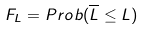Convert formula to latex. <formula><loc_0><loc_0><loc_500><loc_500>F _ { L } = P r o b ( \overline { L } \leq L )</formula> 